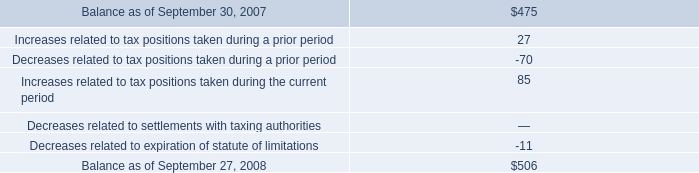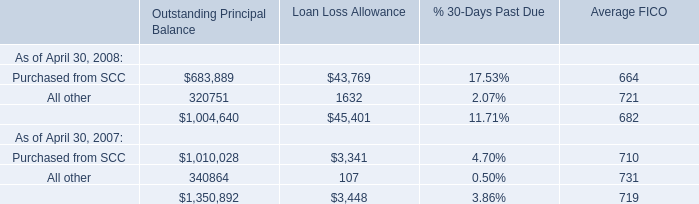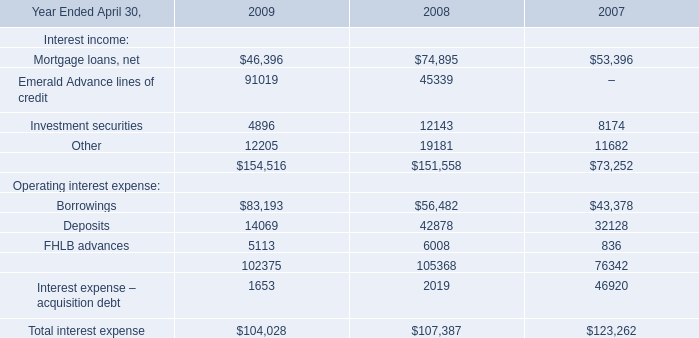In the year with the most Purchased from SCC , what is the growth rate of All other? 
Computations: ((((320751 + 1632) + 721) - ((340864 + 107) + 731)) / ((320751 + 1632) + 721))
Answer: -0.05756. 